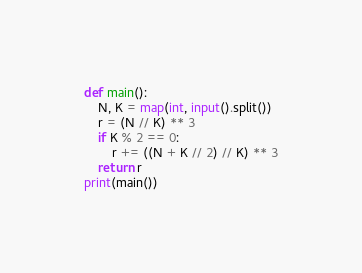Convert code to text. <code><loc_0><loc_0><loc_500><loc_500><_Python_>def main():
    N, K = map(int, input().split())
    r = (N // K) ** 3
    if K % 2 == 0:
        r += ((N + K // 2) // K) ** 3
    return r
print(main())
</code> 